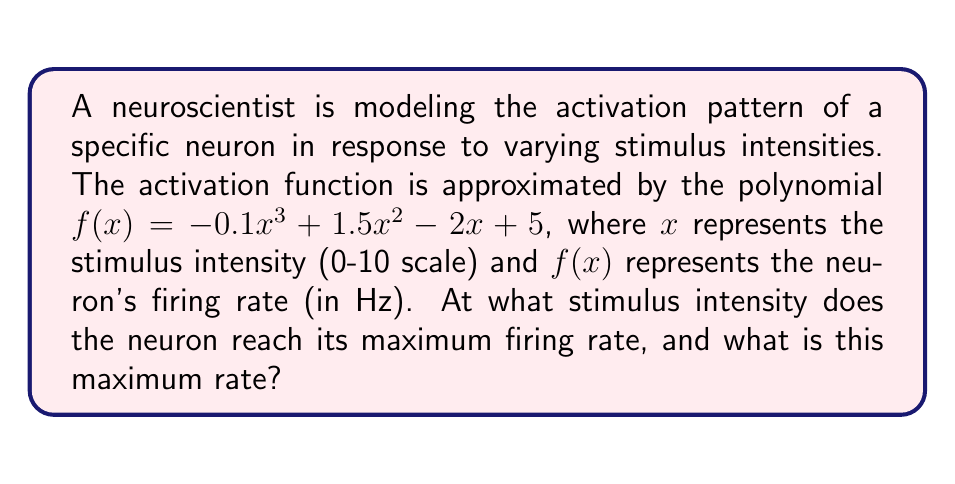Show me your answer to this math problem. To find the maximum firing rate and the corresponding stimulus intensity, we need to follow these steps:

1) Find the derivative of the function:
   $f'(x) = -0.3x^2 + 3x - 2$

2) Set the derivative equal to zero to find critical points:
   $-0.3x^2 + 3x - 2 = 0$

3) Solve this quadratic equation:
   $a = -0.3$, $b = 3$, $c = -2$
   Using the quadratic formula: $x = \frac{-b \pm \sqrt{b^2 - 4ac}}{2a}$
   
   $x = \frac{-3 \pm \sqrt{3^2 - 4(-0.3)(-2)}}{2(-0.3)}$
   $x = \frac{-3 \pm \sqrt{9 - 2.4}}{-0.6}$
   $x = \frac{-3 \pm \sqrt{6.6}}{-0.6}$
   $x = \frac{-3 \pm 2.57}{-0.6}$

   This gives us two solutions:
   $x_1 = \frac{-3 + 2.57}{-0.6} = 0.72$
   $x_2 = \frac{-3 - 2.57}{-0.6} = 9.28$

4) The second derivative is $f''(x) = -0.6x + 3$. At $x = 0.72$, $f''(0.72) = 2.57 > 0$, indicating a local minimum. At $x = 9.28$, $f''(9.28) = -2.57 < 0$, indicating a local maximum.

5) Calculate the firing rate at $x = 9.28$:
   $f(9.28) = -0.1(9.28)^3 + 1.5(9.28)^2 - 2(9.28) + 5$
   $= -79.73 + 129.17 - 18.56 + 5 = 35.88$ Hz

Therefore, the maximum firing rate occurs at a stimulus intensity of 9.28 and reaches 35.88 Hz.
Answer: Stimulus intensity: 9.28, Maximum firing rate: 35.88 Hz 